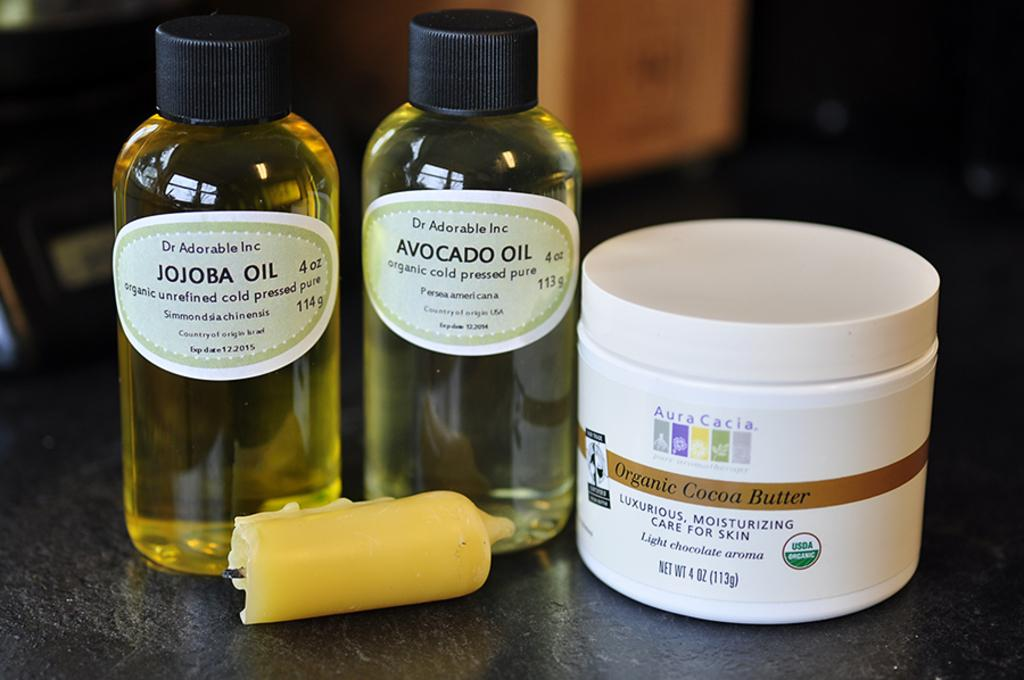<image>
Provide a brief description of the given image. Bottle of Jojoba Oil next to a bottle of Avocado Oil. 